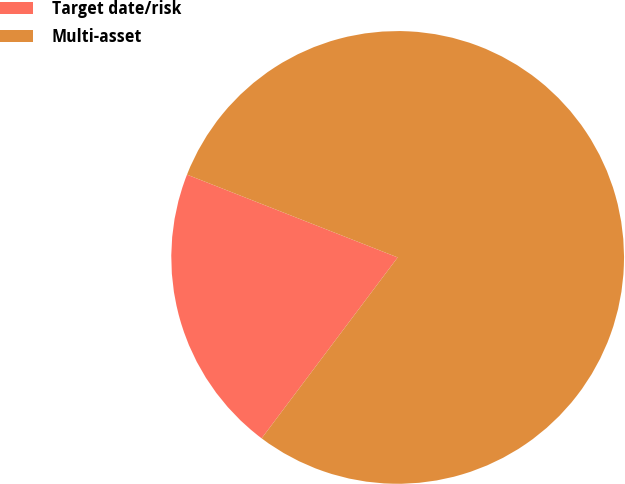<chart> <loc_0><loc_0><loc_500><loc_500><pie_chart><fcel>Target date/risk<fcel>Multi-asset<nl><fcel>20.7%<fcel>79.3%<nl></chart> 